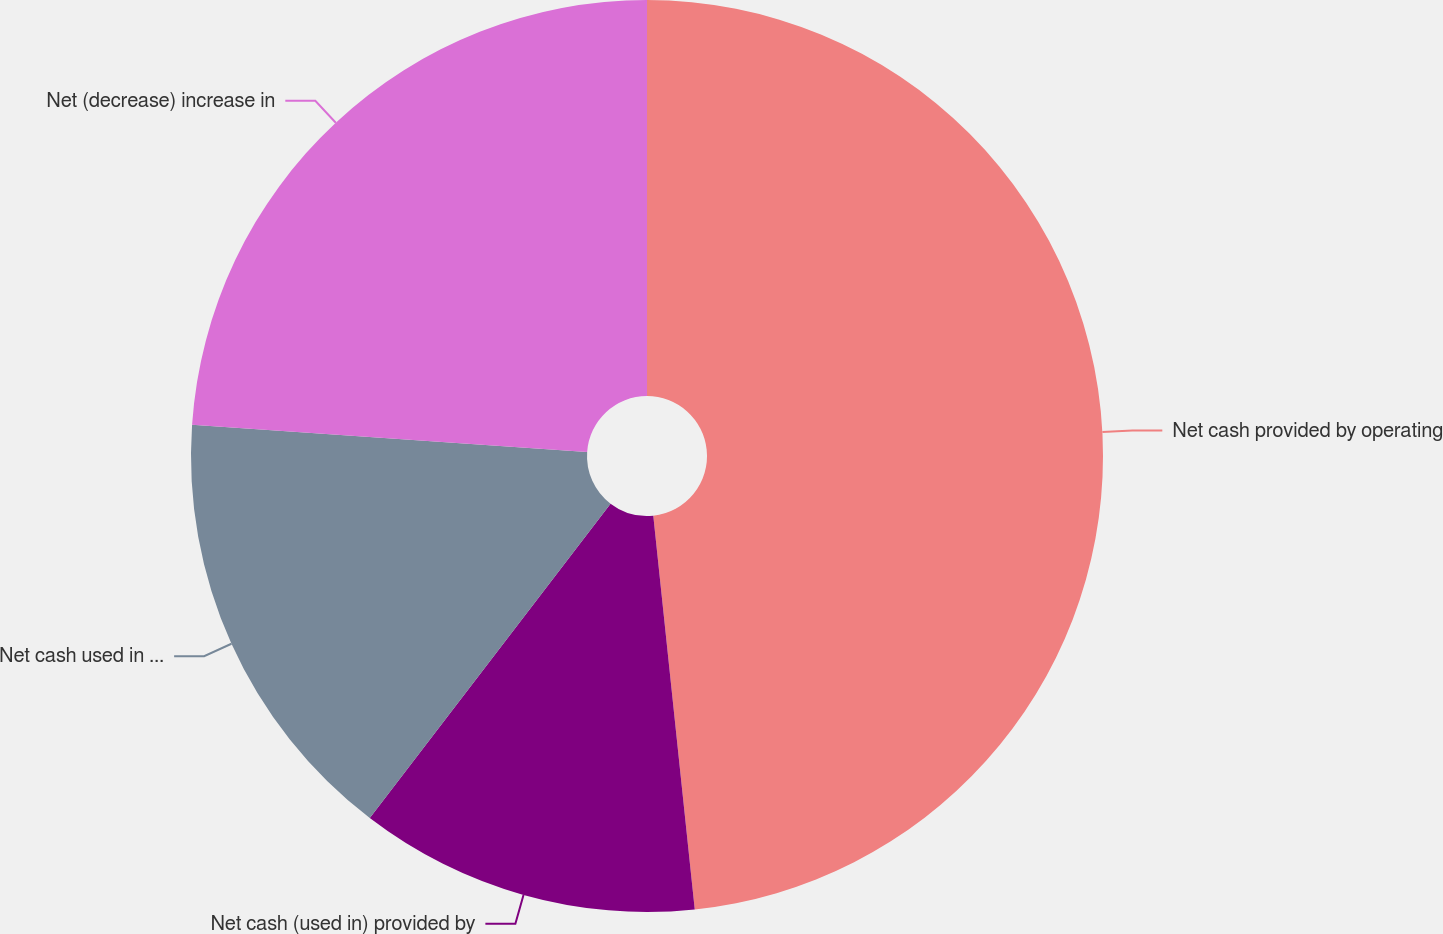Convert chart to OTSL. <chart><loc_0><loc_0><loc_500><loc_500><pie_chart><fcel>Net cash provided by operating<fcel>Net cash (used in) provided by<fcel>Net cash used in financing<fcel>Net (decrease) increase in<nl><fcel>48.33%<fcel>12.07%<fcel>15.69%<fcel>23.91%<nl></chart> 